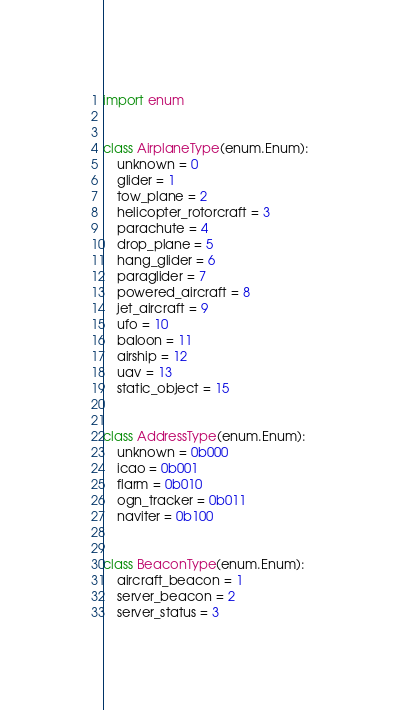<code> <loc_0><loc_0><loc_500><loc_500><_Python_>import enum


class AirplaneType(enum.Enum):
    unknown = 0
    glider = 1
    tow_plane = 2
    helicopter_rotorcraft = 3
    parachute = 4
    drop_plane = 5
    hang_glider = 6
    paraglider = 7
    powered_aircraft = 8
    jet_aircraft = 9
    ufo = 10
    baloon = 11
    airship = 12
    uav = 13
    static_object = 15


class AddressType(enum.Enum):
    unknown = 0b000
    icao = 0b001
    flarm = 0b010
    ogn_tracker = 0b011
    naviter = 0b100


class BeaconType(enum.Enum):
    aircraft_beacon = 1
    server_beacon = 2
    server_status = 3
</code> 